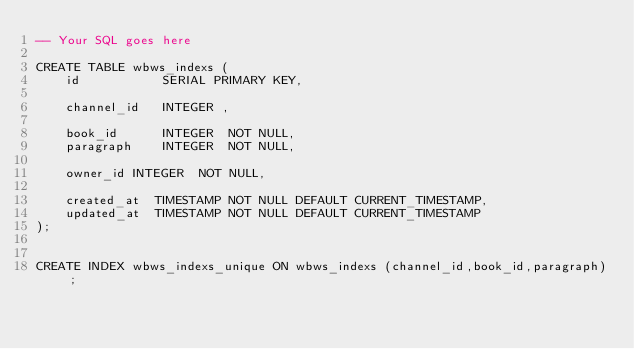<code> <loc_0><loc_0><loc_500><loc_500><_SQL_>-- Your SQL goes here

CREATE TABLE wbws_indexs (
    id           SERIAL PRIMARY KEY,

    channel_id   INTEGER ,
    
    book_id      INTEGER  NOT NULL,
    paragraph    INTEGER  NOT NULL,

    owner_id INTEGER  NOT NULL,

    created_at  TIMESTAMP NOT NULL DEFAULT CURRENT_TIMESTAMP,
    updated_at  TIMESTAMP NOT NULL DEFAULT CURRENT_TIMESTAMP
);


CREATE INDEX wbws_indexs_unique ON wbws_indexs (channel_id,book_id,paragraph);

</code> 